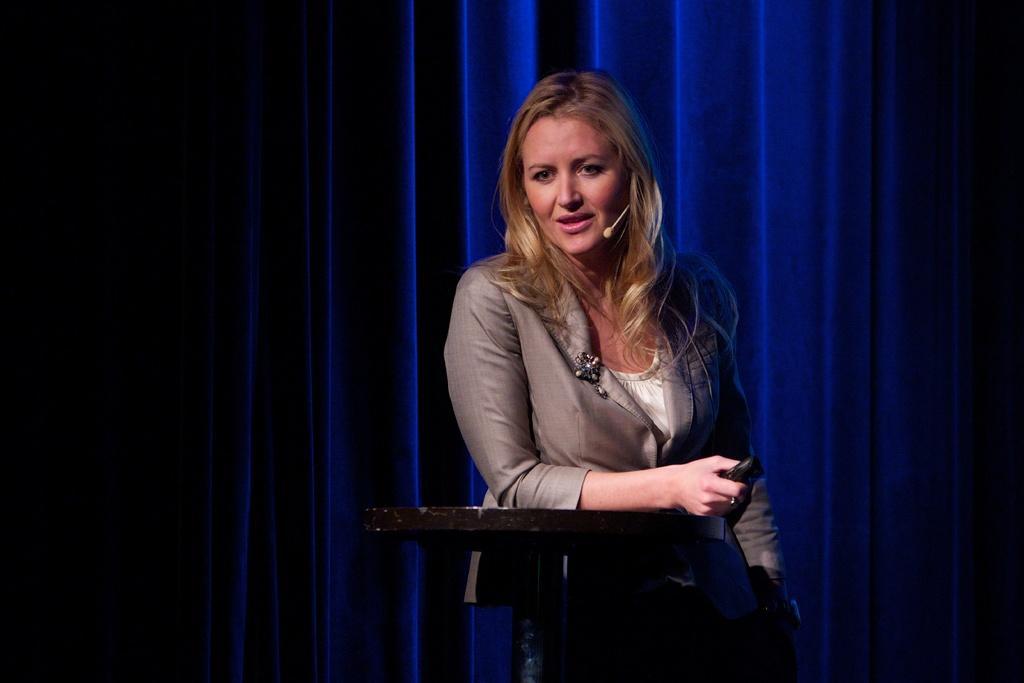Please provide a concise description of this image. In the center of the image a lady is standing and holding an object in her hand. And we can see a table is present in the middle of the image. In the background of the image curtain is there. 